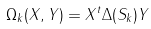Convert formula to latex. <formula><loc_0><loc_0><loc_500><loc_500>\Omega _ { k } ( X , Y ) = X ^ { t } \Delta ( S _ { k } ) Y</formula> 